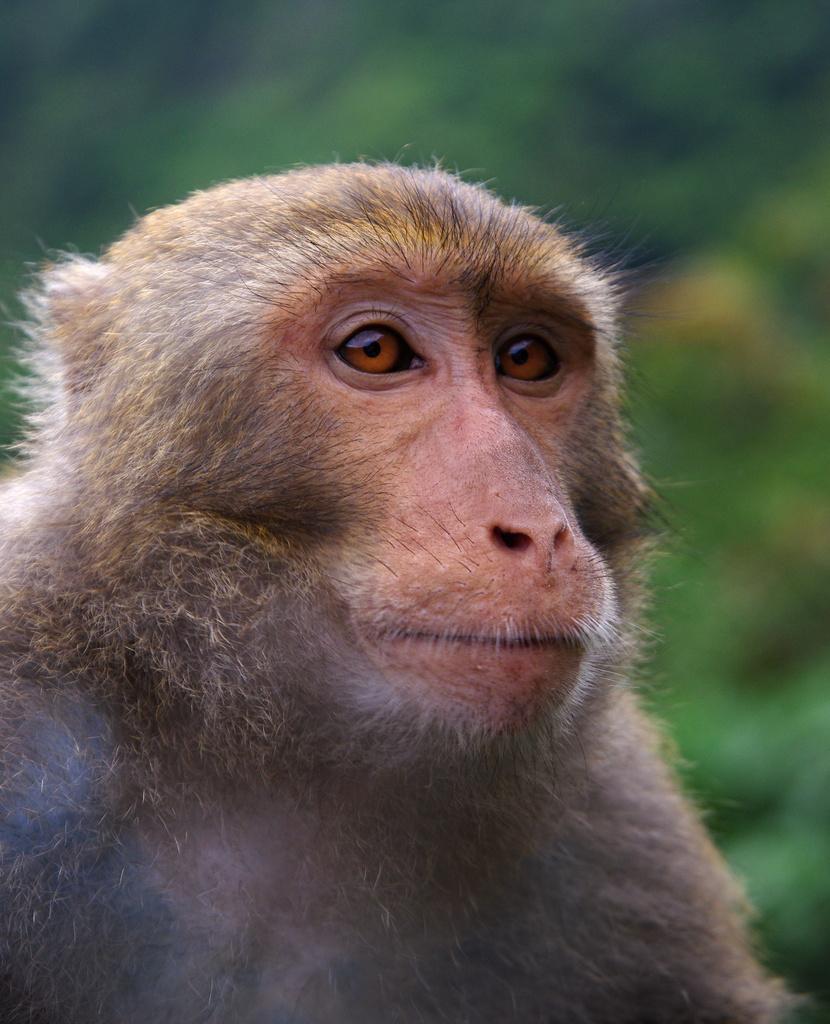Please provide a concise description of this image. In the foreground of the image there is a monkey. The background of the image is blur. 